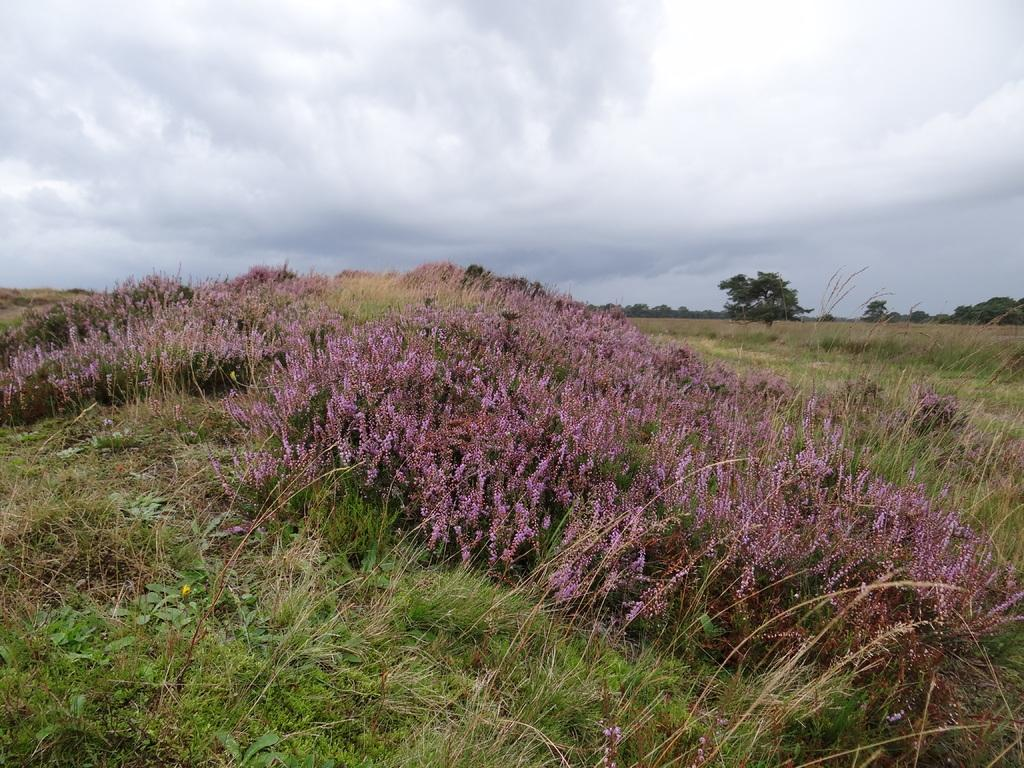What type of plants can be seen in the image? There are plants with purple flowers in the image. What can be seen in the background of the image? There are trees, plants, and the sky visible in the background of the image. What type of meal is being prepared in the image? There is no indication of a meal being prepared in the image; it primarily features plants and the background. 